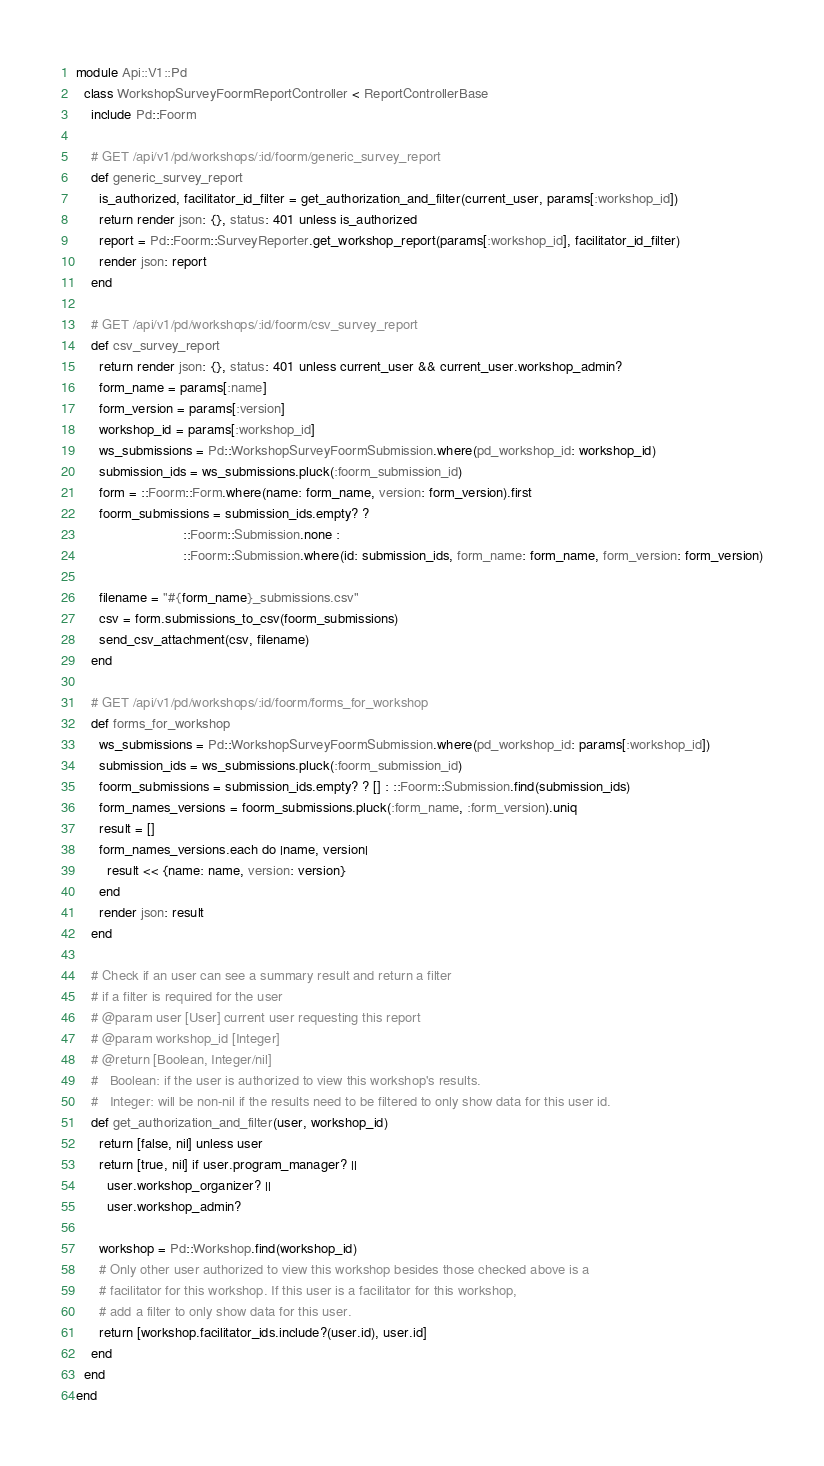<code> <loc_0><loc_0><loc_500><loc_500><_Ruby_>module Api::V1::Pd
  class WorkshopSurveyFoormReportController < ReportControllerBase
    include Pd::Foorm

    # GET /api/v1/pd/workshops/:id/foorm/generic_survey_report
    def generic_survey_report
      is_authorized, facilitator_id_filter = get_authorization_and_filter(current_user, params[:workshop_id])
      return render json: {}, status: 401 unless is_authorized
      report = Pd::Foorm::SurveyReporter.get_workshop_report(params[:workshop_id], facilitator_id_filter)
      render json: report
    end

    # GET /api/v1/pd/workshops/:id/foorm/csv_survey_report
    def csv_survey_report
      return render json: {}, status: 401 unless current_user && current_user.workshop_admin?
      form_name = params[:name]
      form_version = params[:version]
      workshop_id = params[:workshop_id]
      ws_submissions = Pd::WorkshopSurveyFoormSubmission.where(pd_workshop_id: workshop_id)
      submission_ids = ws_submissions.pluck(:foorm_submission_id)
      form = ::Foorm::Form.where(name: form_name, version: form_version).first
      foorm_submissions = submission_ids.empty? ?
                            ::Foorm::Submission.none :
                            ::Foorm::Submission.where(id: submission_ids, form_name: form_name, form_version: form_version)

      filename = "#{form_name}_submissions.csv"
      csv = form.submissions_to_csv(foorm_submissions)
      send_csv_attachment(csv, filename)
    end

    # GET /api/v1/pd/workshops/:id/foorm/forms_for_workshop
    def forms_for_workshop
      ws_submissions = Pd::WorkshopSurveyFoormSubmission.where(pd_workshop_id: params[:workshop_id])
      submission_ids = ws_submissions.pluck(:foorm_submission_id)
      foorm_submissions = submission_ids.empty? ? [] : ::Foorm::Submission.find(submission_ids)
      form_names_versions = foorm_submissions.pluck(:form_name, :form_version).uniq
      result = []
      form_names_versions.each do |name, version|
        result << {name: name, version: version}
      end
      render json: result
    end

    # Check if an user can see a summary result and return a filter
    # if a filter is required for the user
    # @param user [User] current user requesting this report
    # @param workshop_id [Integer]
    # @return [Boolean, Integer/nil]
    #   Boolean: if the user is authorized to view this workshop's results.
    #   Integer: will be non-nil if the results need to be filtered to only show data for this user id.
    def get_authorization_and_filter(user, workshop_id)
      return [false, nil] unless user
      return [true, nil] if user.program_manager? ||
        user.workshop_organizer? ||
        user.workshop_admin?

      workshop = Pd::Workshop.find(workshop_id)
      # Only other user authorized to view this workshop besides those checked above is a
      # facilitator for this workshop. If this user is a facilitator for this workshop,
      # add a filter to only show data for this user.
      return [workshop.facilitator_ids.include?(user.id), user.id]
    end
  end
end
</code> 